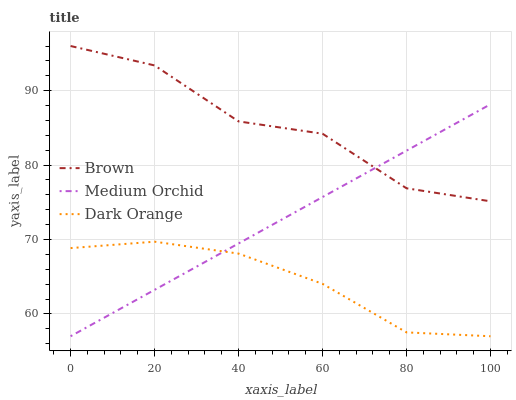Does Dark Orange have the minimum area under the curve?
Answer yes or no. Yes. Does Brown have the maximum area under the curve?
Answer yes or no. Yes. Does Medium Orchid have the minimum area under the curve?
Answer yes or no. No. Does Medium Orchid have the maximum area under the curve?
Answer yes or no. No. Is Medium Orchid the smoothest?
Answer yes or no. Yes. Is Brown the roughest?
Answer yes or no. Yes. Is Dark Orange the smoothest?
Answer yes or no. No. Is Dark Orange the roughest?
Answer yes or no. No. Does Medium Orchid have the lowest value?
Answer yes or no. Yes. Does Brown have the highest value?
Answer yes or no. Yes. Does Medium Orchid have the highest value?
Answer yes or no. No. Is Dark Orange less than Brown?
Answer yes or no. Yes. Is Brown greater than Dark Orange?
Answer yes or no. Yes. Does Medium Orchid intersect Dark Orange?
Answer yes or no. Yes. Is Medium Orchid less than Dark Orange?
Answer yes or no. No. Is Medium Orchid greater than Dark Orange?
Answer yes or no. No. Does Dark Orange intersect Brown?
Answer yes or no. No. 